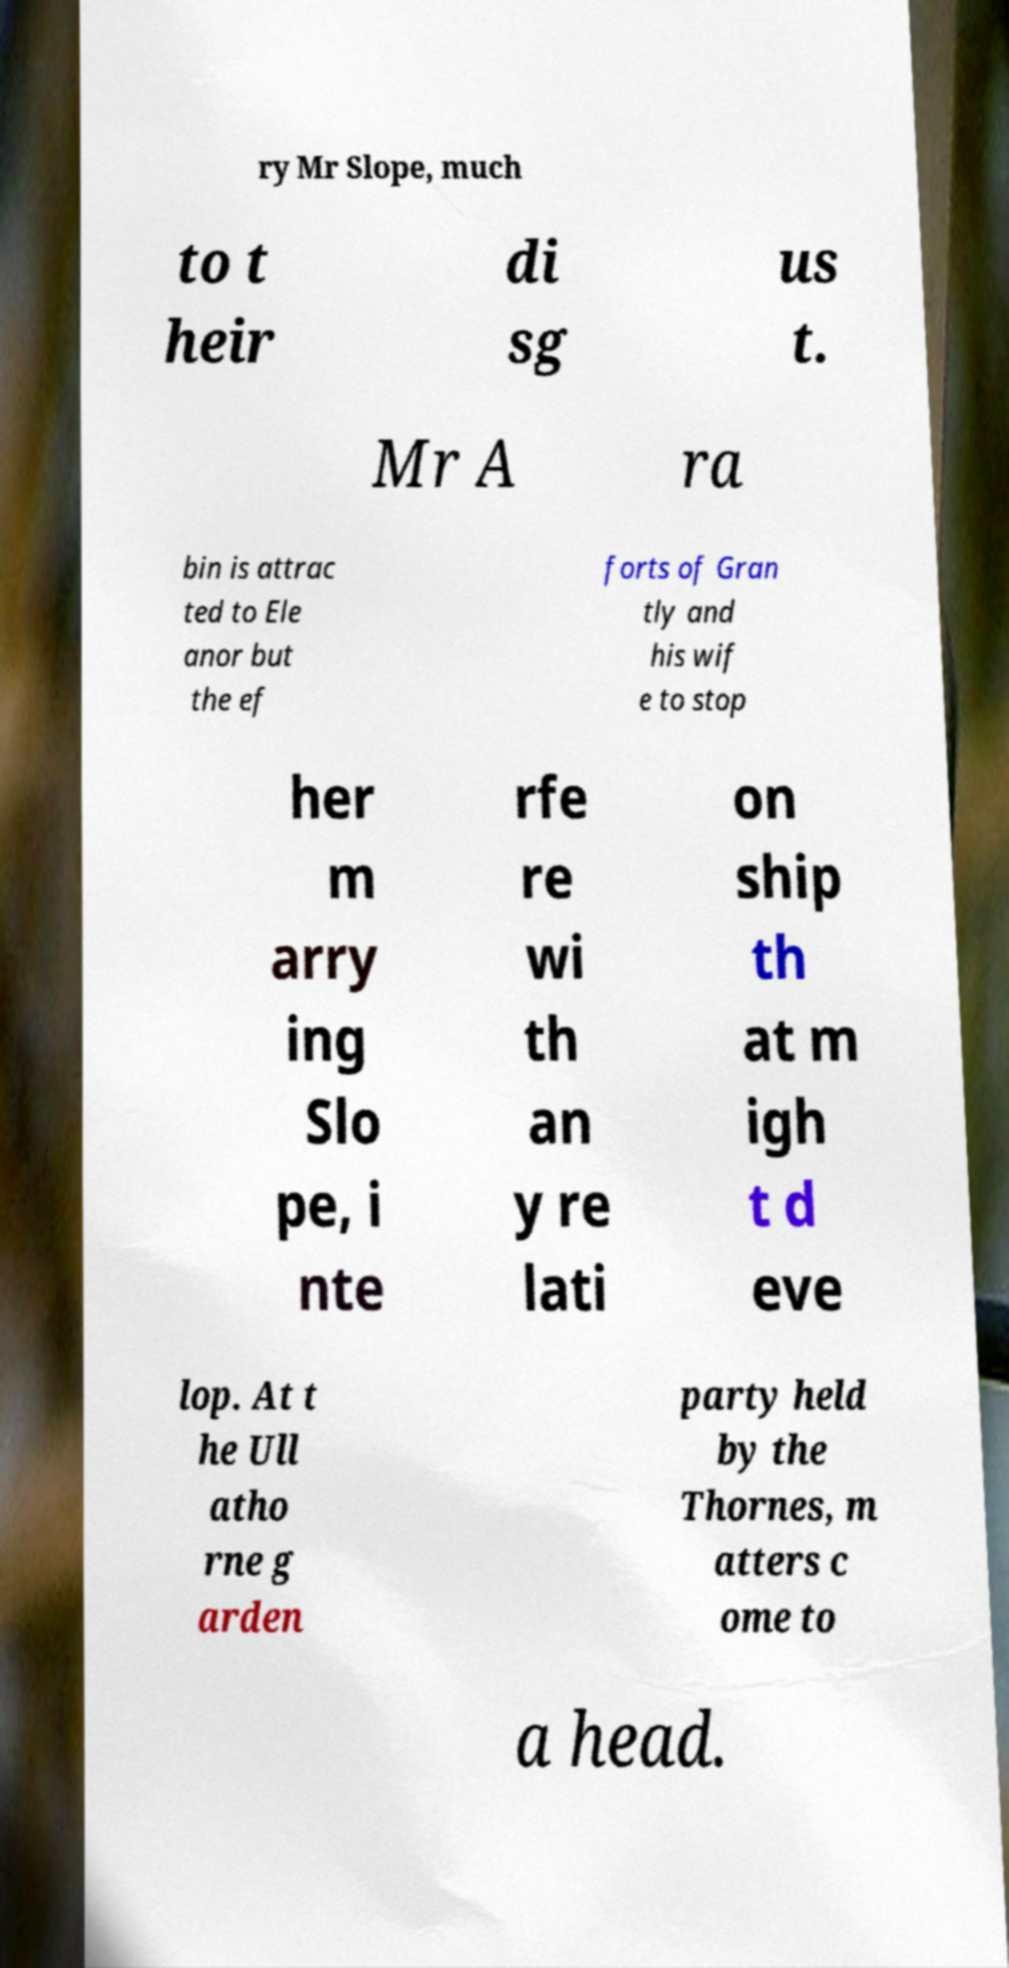There's text embedded in this image that I need extracted. Can you transcribe it verbatim? ry Mr Slope, much to t heir di sg us t. Mr A ra bin is attrac ted to Ele anor but the ef forts of Gran tly and his wif e to stop her m arry ing Slo pe, i nte rfe re wi th an y re lati on ship th at m igh t d eve lop. At t he Ull atho rne g arden party held by the Thornes, m atters c ome to a head. 